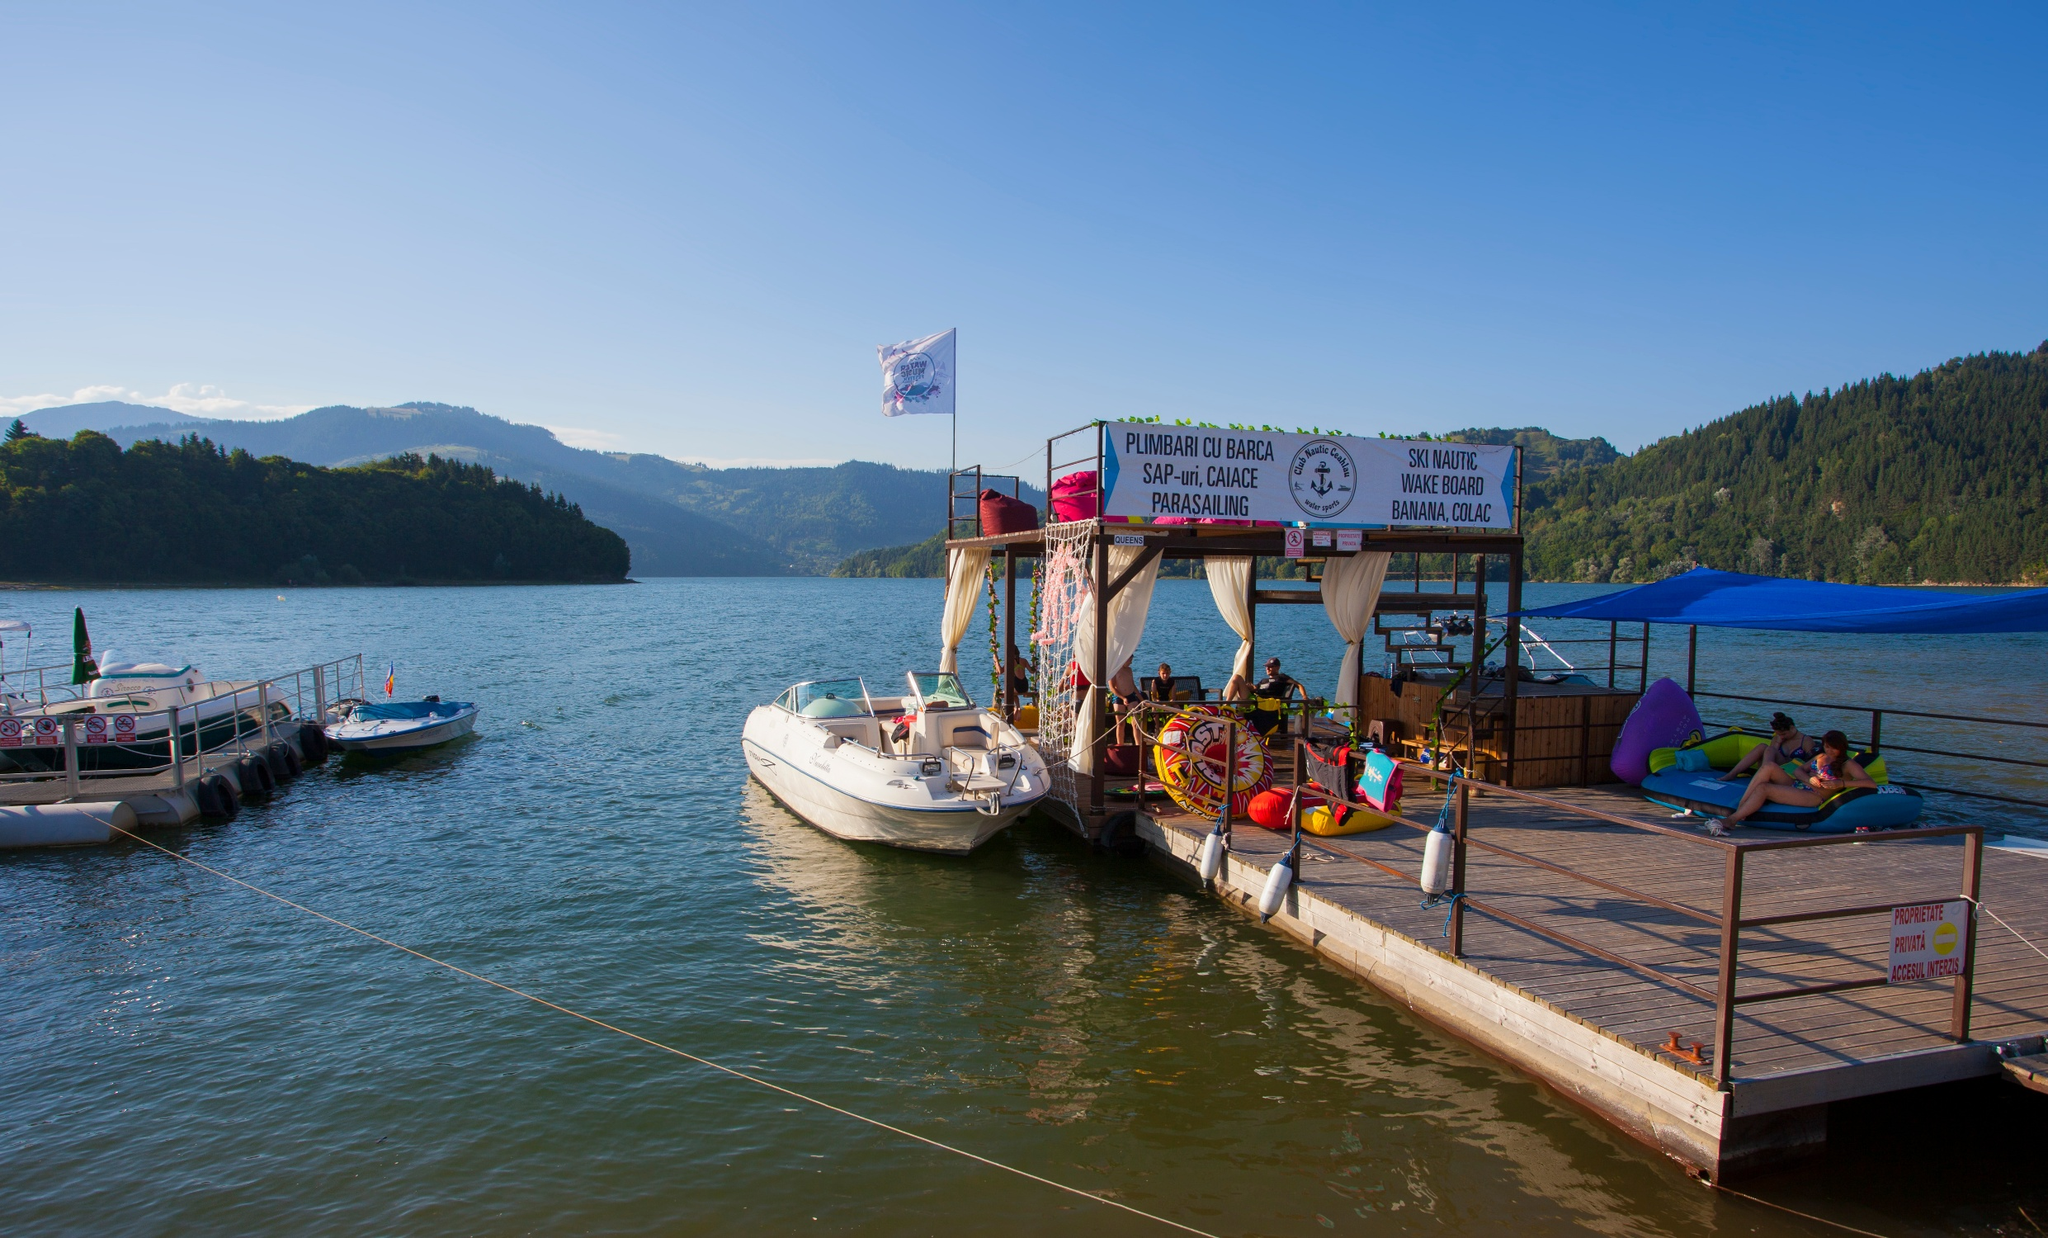Can you tell me more about the recreational activities available at this location? Certainly! This lakeside spot offers a variety of water sports. The signage indicates activities such as boat trips, paddleboarding, as well as more adrenaline-inducing options like water skiing, wakeboarding, and parasailing. There appears to be equipment available for rent, catering to different age groups and skill levels, making this an ideal place for both beginners and enthusiasts looking to enjoy the water. How would someone typically spend a day here? A visitor could start their day by taking a peaceful boat ride to explore the lake, followed by an adventurous water skiing or wakeboarding session. After the thrill, they might relax on the floats or the deck, soaking up the sun. The location is suitable for a full day of activities, including taking breaks for refreshments and enjoying the beautiful panoramic views of the surrounding nature. 